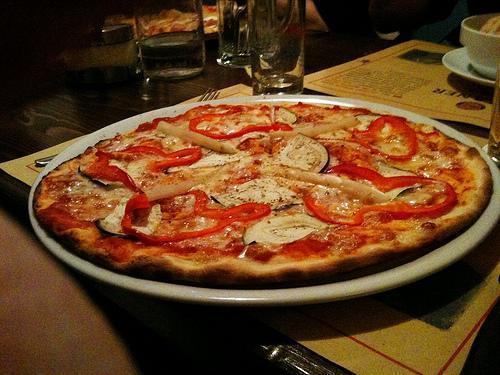How many pizzas are visible?
Give a very brief answer. 1. 